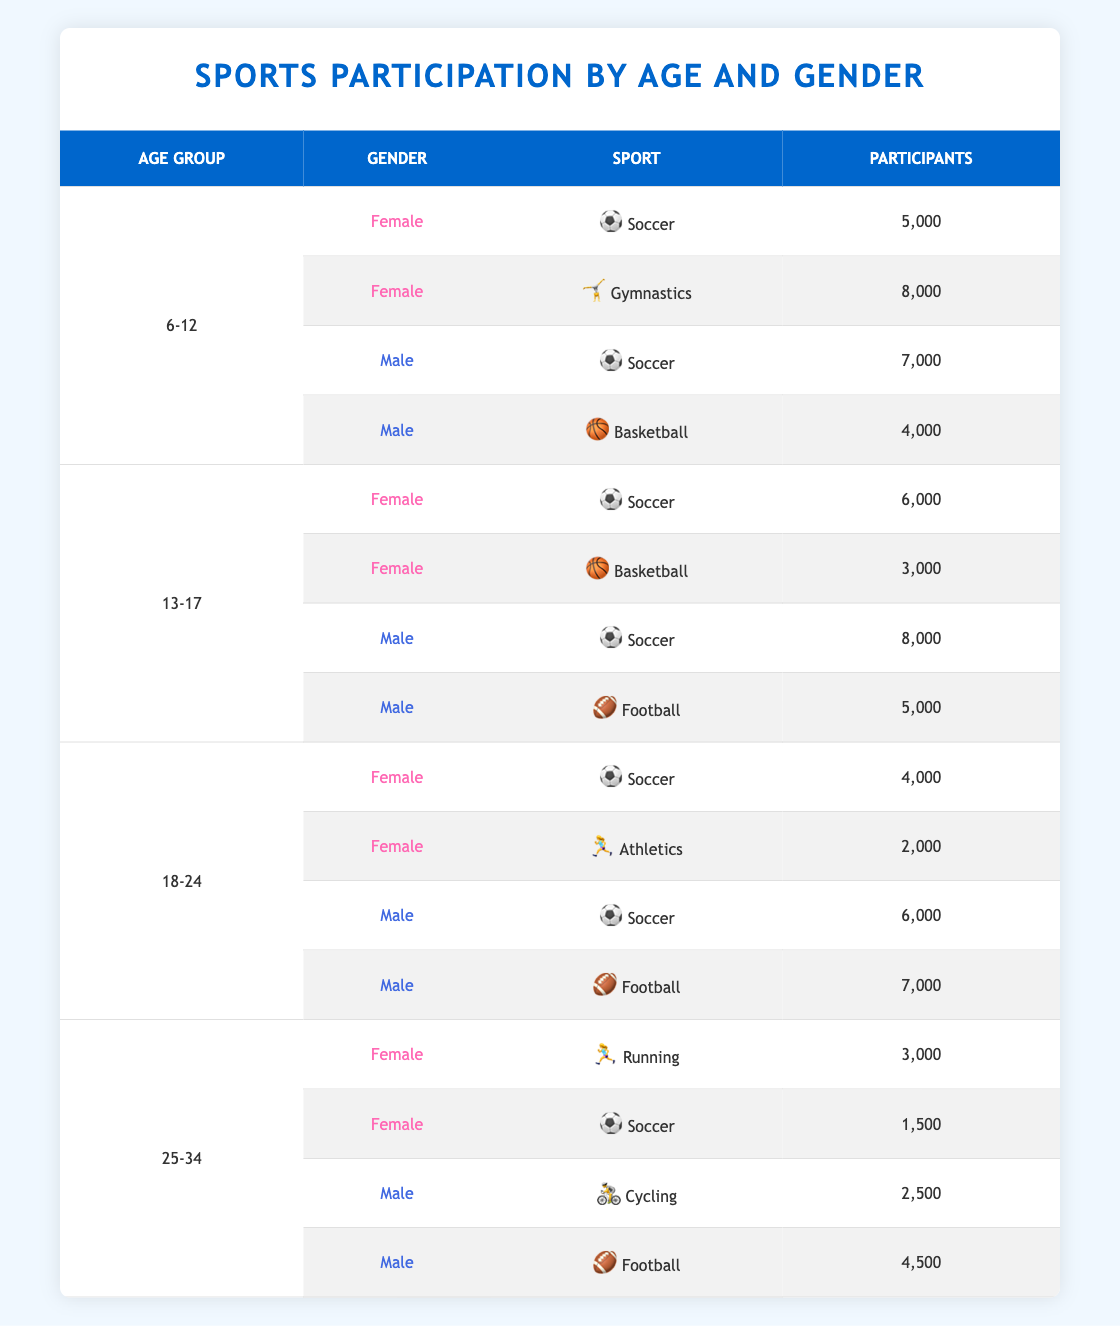What is the total number of female participants in soccer across all age groups? To find this, I will add the number of female participants in soccer from each age group. In the 6-12 age group, there are 5,000 participants; in the 13-17 age group, there are 6,000 participants; and in the 18-24 age group, there are 4,000 participants. Hence, the total is 5,000 + 6,000 + 4,000 = 15,000.
Answer: 15,000 Which age group has the highest number of male participants in football? I need to check each age group's male football participants. In the 6-12 age group, there are 0 participants; in the 13-17 age group, there are 5,000 participants; in the 18-24 age group, there are 7,000 participants; and in the 25-34 age group, there are 4,500 participants. The highest number is from the 18-24 age group with 7,000 participants.
Answer: 18-24 Is there a higher number of female participants in gymnastics or soccer in the age group 6-12? In the 6-12 age group, there are 8,000 female participants in gymnastics and 5,000 in soccer. Therefore, gymnastics has a higher number.
Answer: Yes What is the difference in the number of male participants in soccer between the age groups 13-17 and 18-24? From the table, in the 13-17 age group, there are 8,000 male participants in soccer, and in the 18-24 age group, there are 6,000 male participants. The difference is 8,000 - 6,000 = 2,000 participants.
Answer: 2,000 How many total participants are there for male sports (soccer, football, and cycling) in the age group 25-34? I will add the male participants for each sport in the 25-34 age group, which includes 0 for soccer, 4,500 for football, and 2,500 for cycling. So, the total is 0 + 4,500 + 2,500 = 7,000 participants.
Answer: 7,000 Are there more female participants in athletics than in gymnastics in the age group 18-24? In the 18-24 age group, there are 2,000 female participants in athletics and 0 in gymnastics. Therefore, athletics has more participants.
Answer: No What is the total number of participants in basketball across all age groups for males? I will check the male participants in basketball by age group. For the 6-12 age group, there are 4,000; for the 13-17 age group, there are 0; for the 18-24 age group, there are 0; and for the 25-34 age group, there are also 0. So the total is 4,000.
Answer: 4,000 In the age group 25-34, how many fewer female participants are there in soccer compared to running? In the 25-34 age group, there are 1,500 female participants in soccer and 3,000 in running. The difference is 3,000 - 1,500 = 1,500.
Answer: 1,500 Which sport has the highest number of participants in the age group 13-17, and what are the participant numbers? In the 13-17 age group, soccer has 6,000 participants for females and 8,000 for males, totaling 14,000. No other sport surpasses this number. Hence, soccer has the highest number of participants.
Answer: Soccer, 14,000 